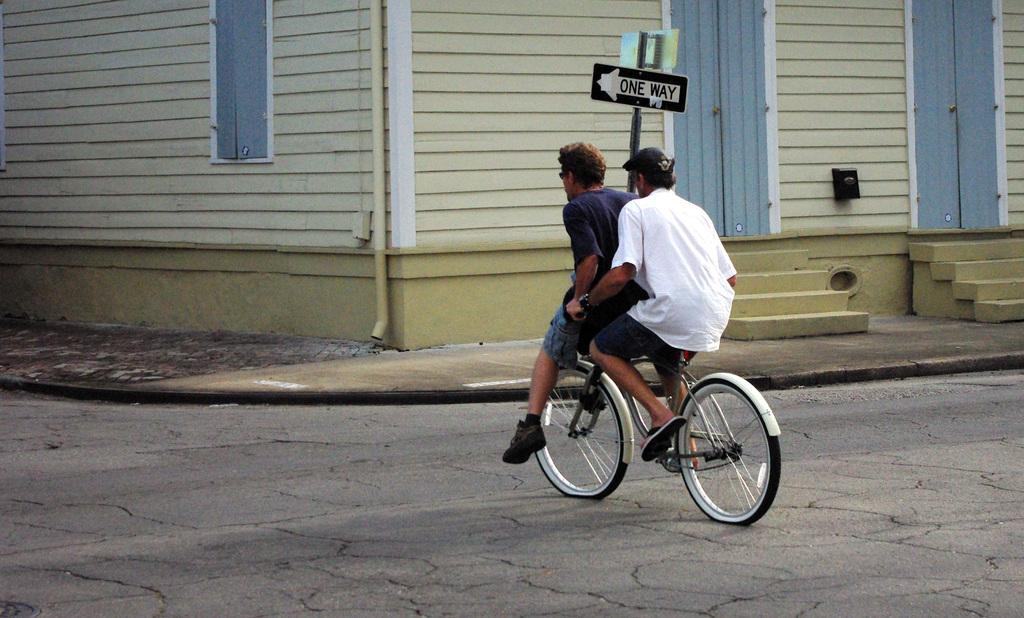Please provide a concise description of this image. In this picture we can see two persons are seated on the bicycle, and one person is riding a bicycle on the road, and we can see a sign board, plastic pipe, and couple of buildings. 